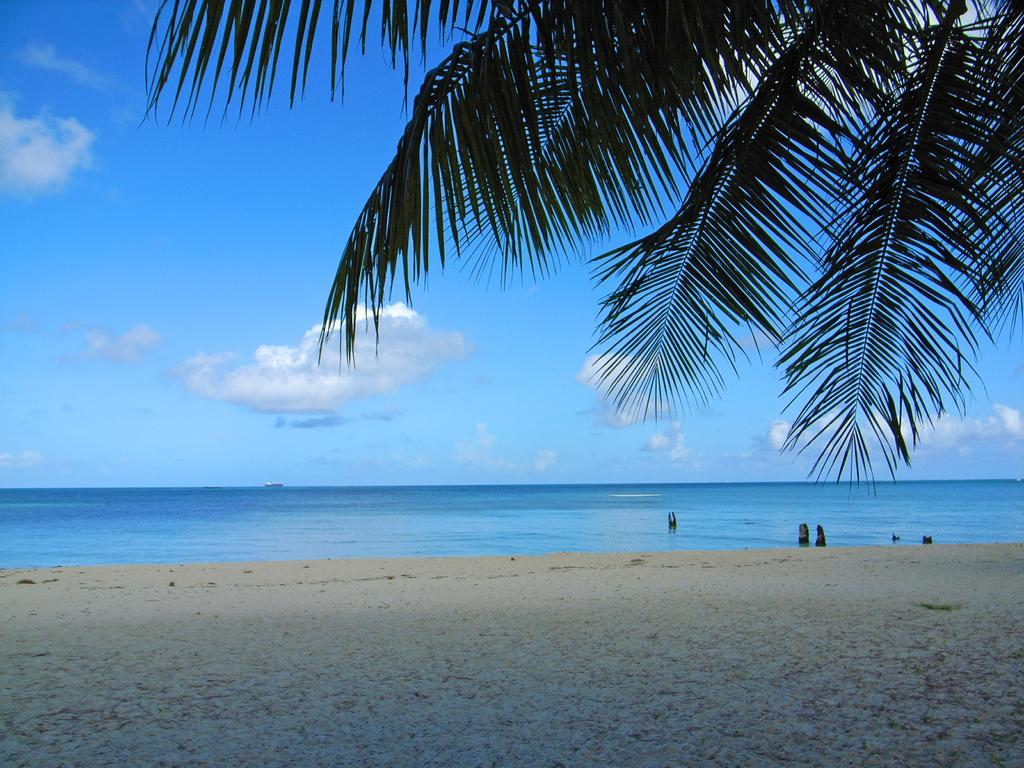What natural feature is the main subject of the image? There is an ocean in the image. What else can be seen in the sky in the image? There is a sky visible in the image. What type of vegetation is present at the top of the image? There are leaves of trees at the top of the image. Where is the market located in the image? There is no market present in the image. What type of division can be seen between the ocean and the sky in the image? The image does not depict a division between the ocean and the sky; it shows them blending together. 